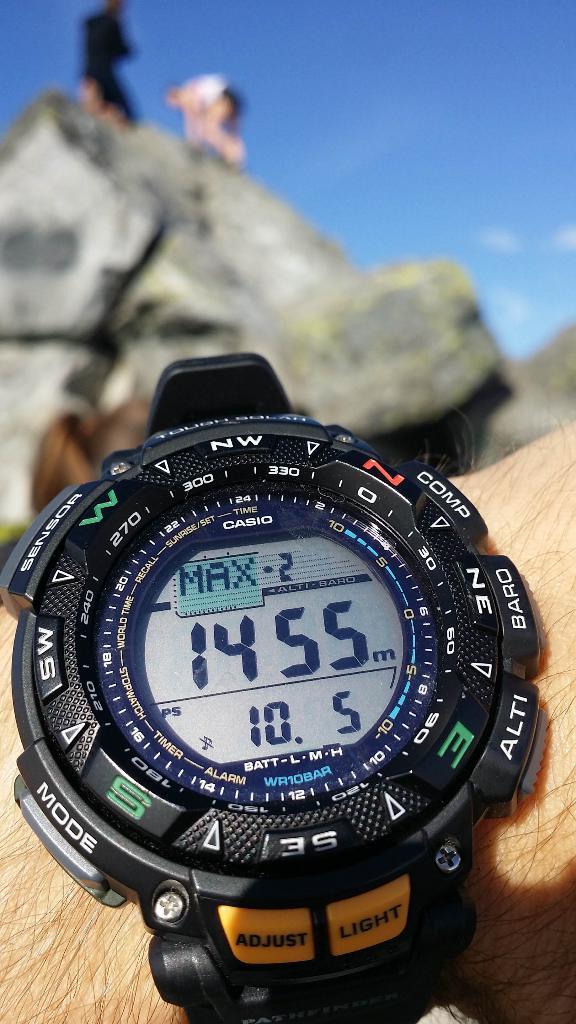What do the yellow buttons say?
Offer a very short reply. Adjust light. Who makes this watch?
Provide a succinct answer. Casio. 